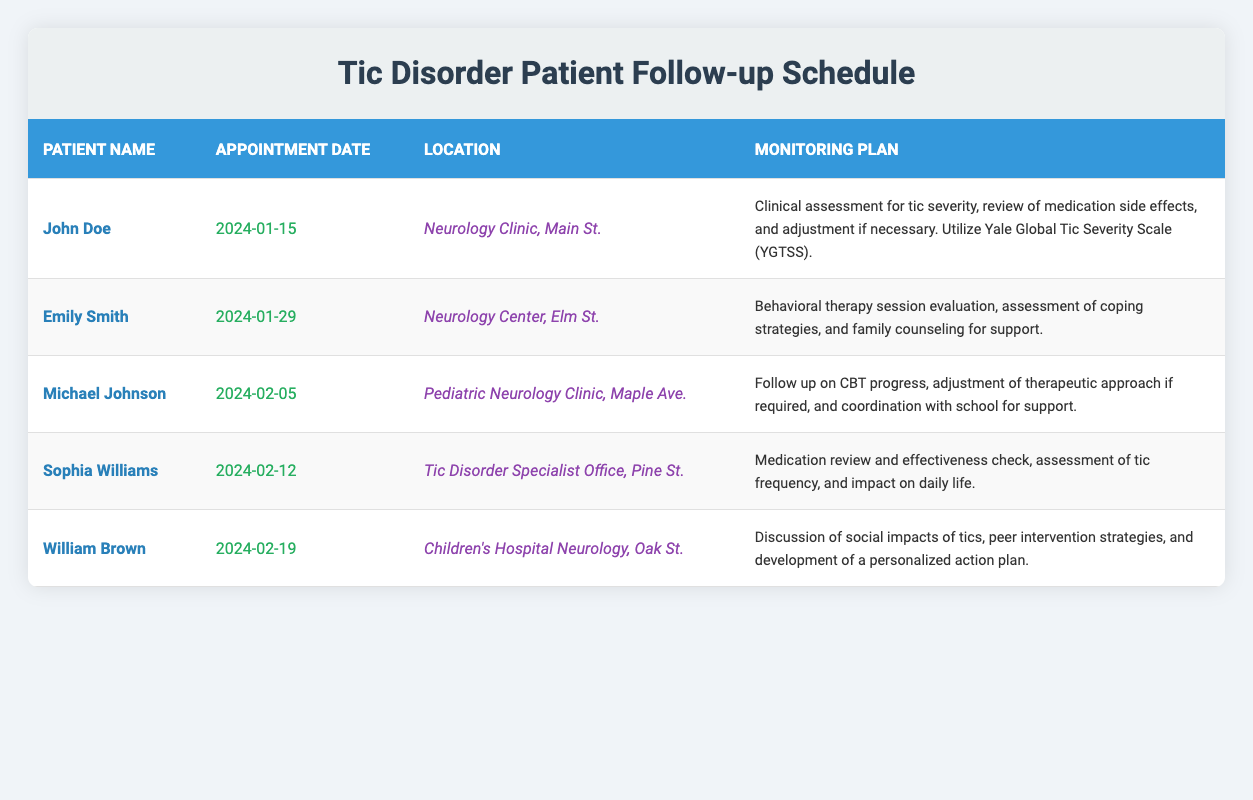What is the appointment date for John Doe? The appointment date for John Doe is listed directly in the table under the column labeled "Appointment Date." It states "2024-01-15."
Answer: 2024-01-15 Where is Emily Smith's follow-up appointment located? The location for Emily Smith’s follow-up appointment is specified in the table under the "Location" column. It mentions "Neurology Center, Elm St."
Answer: Neurology Center, Elm St How many patients have appointments scheduled in February 2024? Looking through the table, I count the entries for February: Michael Johnson (2024-02-05), Sophia Williams (2024-02-12), and William Brown (2024-02-19). That totals to three patients.
Answer: 3 Is there a follow-up plan for medication review listed for any patient? The monitoring plans show that Sophia Williams has a plan that includes "Medication review and effectiveness check." Thus, there is indeed a follow-up plan for medication review.
Answer: Yes Which patient is scheduled for their appointment first? By examining the "Appointment Date" column, John Doe is scheduled for "2024-01-15," which is the earliest date in the list of appointments when compared to others.
Answer: John Doe What is the primary focus of William Brown's follow-up appointment? The monitoring plan for William Brown indicates a focus on "Discussion of social impacts of tics, peer intervention strategies, and development of a personalized action plan."
Answer: Discussion of social impacts and personalized action plan What is the average interval (in days) between the follow-up appointments listed in January 2024? The appointments in January are John Doe (2024-01-15) and Emily Smith (2024-01-29), which is a 14-day interval. There are only two appointments in this month, thus the average is 14 days.
Answer: 14 days Are any appointments taking place at the same location? No, when reviewing the locations for all patients listed, each appointment seems to be at a different location, thus confirming that there are no overlapping locations for the appointments.
Answer: No Which patient's appointment involves family counseling? Emily Smith's monitoring plan specifically mentions an "assessment of coping strategies, and family counseling for support," indicating that her appointment involves family counseling.
Answer: Emily Smith 